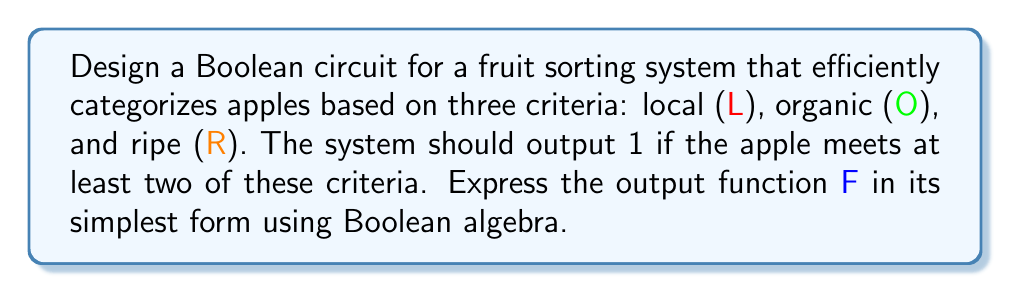Can you solve this math problem? Let's approach this step-by-step:

1) First, we need to define our Boolean function. We want the output to be 1 if at least two of the three criteria are met. This can be expressed as:

   $F = LO + LR + OR - LOR$

2) This expression represents all possible combinations where at least two criteria are met, minus the case where all three are met (to avoid double counting).

3) To simplify this expression, we can use Boolean algebra laws:

   $F = LO + LR + OR - LOR$
   $= LO + LR + OR + LOR$ (since $-LOR = +LOR$ in Boolean algebra)

4) Now we can factor out L:

   $F = L(O + R) + OR$

5) Using the distributive law, we can expand this:

   $F = LO + LR + OR$

6) This is already in its simplest form, known as the Sum of Products (SOP) form.

7) We can verify that this function indeed outputs 1 when at least two criteria are met:
   - If L=1, O=1, R=0: $F = 1 + 0 + 0 = 1$
   - If L=1, O=0, R=1: $F = 0 + 1 + 0 = 1$
   - If L=0, O=1, R=1: $F = 0 + 0 + 1 = 1$
   - If L=1, O=1, R=1: $F = 1 + 1 + 1 = 1$

8) And it outputs 0 when fewer than two criteria are met:
   - If L=1, O=0, R=0: $F = 0 + 0 + 0 = 0$
   - If L=0, O=1, R=0: $F = 0 + 0 + 0 = 0$
   - If L=0, O=0, R=1: $F = 0 + 0 + 0 = 0$
   - If L=0, O=0, R=0: $F = 0 + 0 + 0 = 0$
Answer: $F = LO + LR + OR$ 